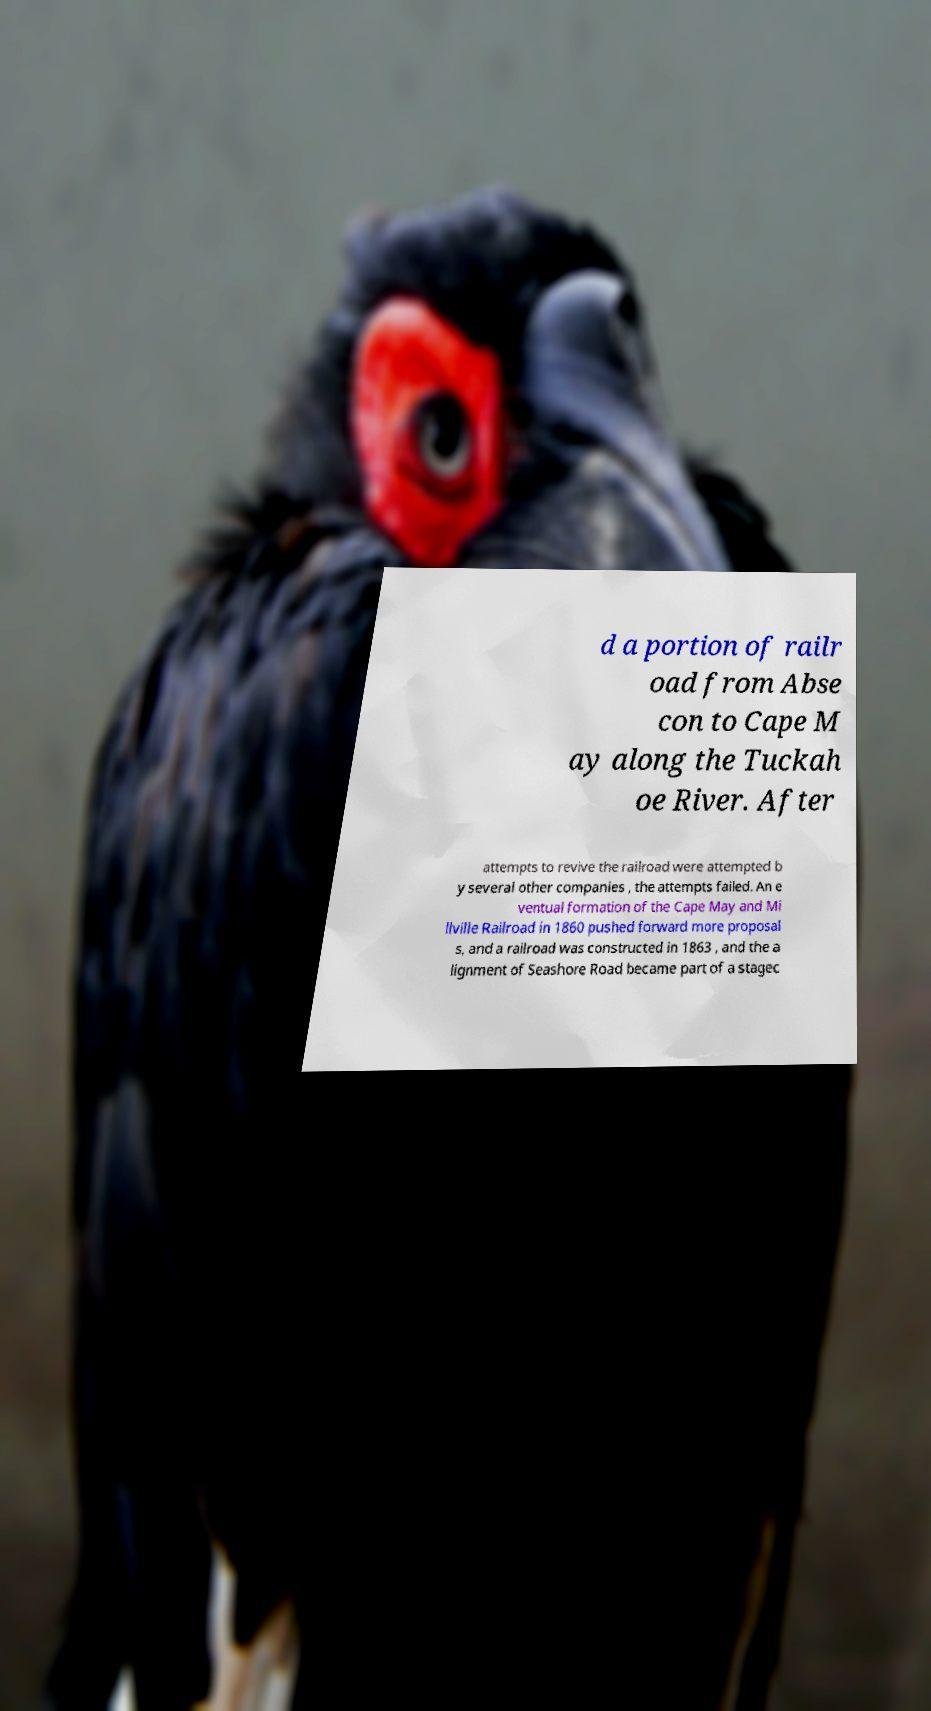I need the written content from this picture converted into text. Can you do that? d a portion of railr oad from Abse con to Cape M ay along the Tuckah oe River. After attempts to revive the railroad were attempted b y several other companies , the attempts failed. An e ventual formation of the Cape May and Mi llville Railroad in 1860 pushed forward more proposal s, and a railroad was constructed in 1863 , and the a lignment of Seashore Road became part of a stagec 